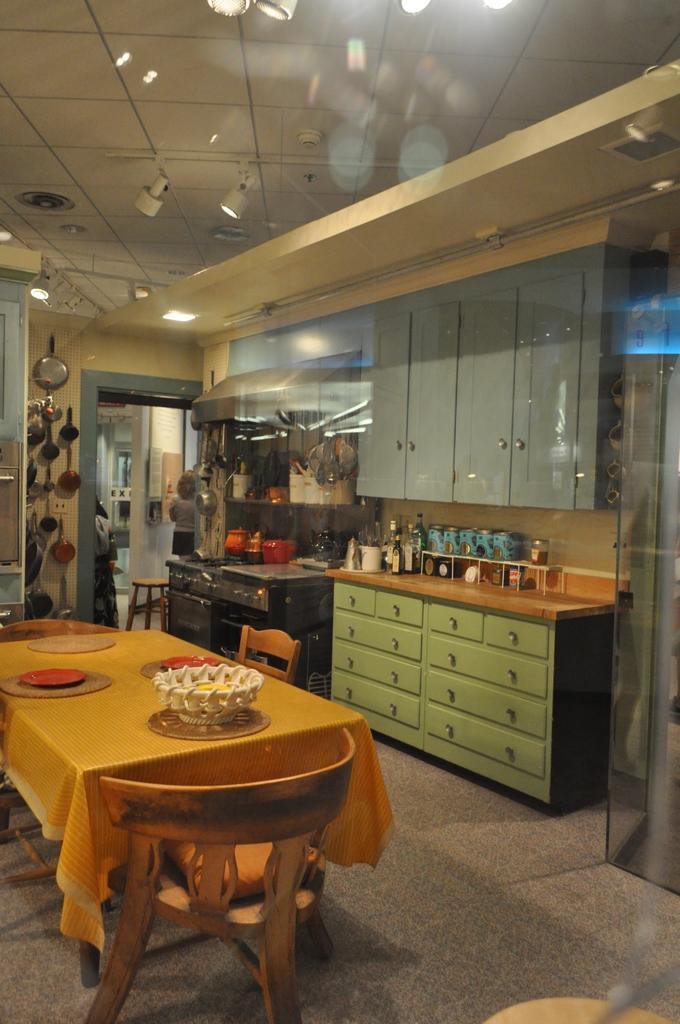Could you give a brief overview of what you see in this image? In this image we can see a table on the floor and plates on it, and here are the chairs, and here is the table and bottles, and some objects on it, and at above her is the roof, and here are the lights. 